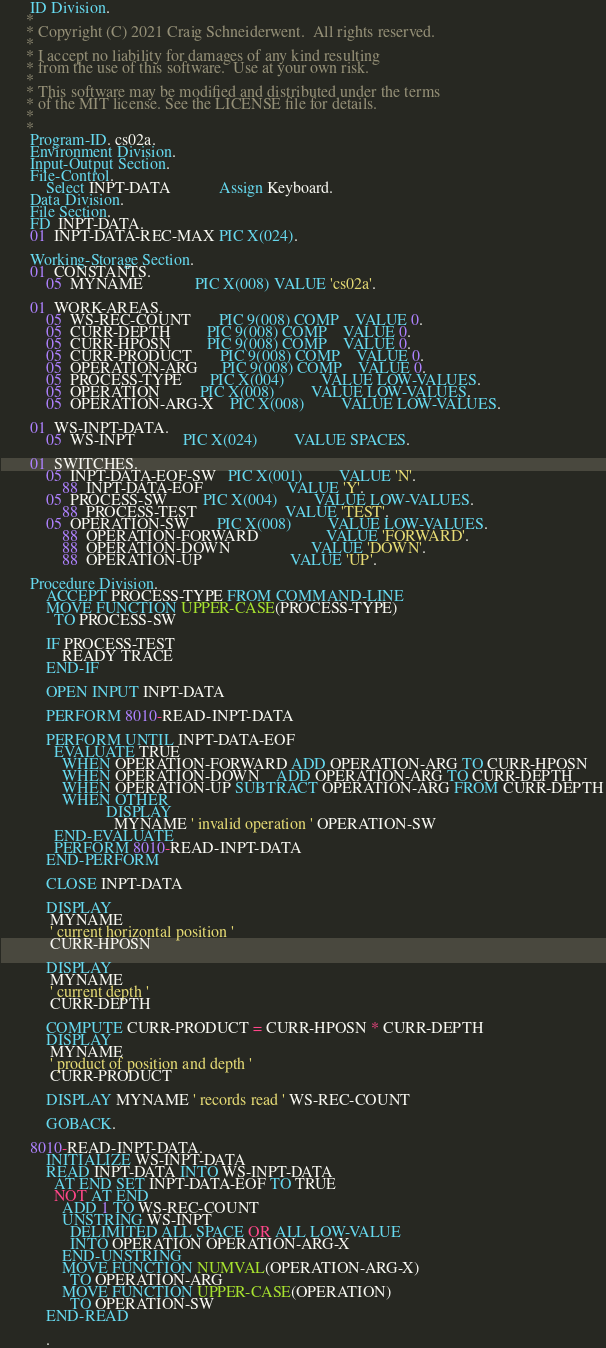<code> <loc_0><loc_0><loc_500><loc_500><_COBOL_>       ID Division.
      * 
      * Copyright (C) 2021 Craig Schneiderwent.  All rights reserved.
      * 
      * I accept no liability for damages of any kind resulting 
      * from the use of this software.  Use at your own risk.
      *
      * This software may be modified and distributed under the terms
      * of the MIT license. See the LICENSE file for details.
      *
      *
       Program-ID. cs02a.
       Environment Division.
       Input-Output Section.
       File-Control.
           Select INPT-DATA            Assign Keyboard.
       Data Division.
       File Section.
       FD  INPT-DATA.
       01  INPT-DATA-REC-MAX PIC X(024).

       Working-Storage Section.
       01  CONSTANTS.
           05  MYNAME             PIC X(008) VALUE 'cs02a'.

       01  WORK-AREAS.
           05  WS-REC-COUNT       PIC 9(008) COMP    VALUE 0.
           05  CURR-DEPTH         PIC 9(008) COMP    VALUE 0.
           05  CURR-HPOSN         PIC 9(008) COMP    VALUE 0.
           05  CURR-PRODUCT       PIC 9(008) COMP    VALUE 0.
           05  OPERATION-ARG      PIC 9(008) COMP    VALUE 0.
           05  PROCESS-TYPE       PIC X(004)         VALUE LOW-VALUES.
           05  OPERATION          PIC X(008)         VALUE LOW-VALUES.
           05  OPERATION-ARG-X    PIC X(008)         VALUE LOW-VALUES.

       01  WS-INPT-DATA.
           05  WS-INPT            PIC X(024)         VALUE SPACES.

       01  SWITCHES.
           05  INPT-DATA-EOF-SW   PIC X(001)         VALUE 'N'.
               88  INPT-DATA-EOF                     VALUE 'Y'.
           05  PROCESS-SW         PIC X(004)         VALUE LOW-VALUES.
               88  PROCESS-TEST                      VALUE 'TEST'.
           05  OPERATION-SW       PIC X(008)         VALUE LOW-VALUES.
               88  OPERATION-FORWARD                 VALUE 'FORWARD'.
               88  OPERATION-DOWN                    VALUE 'DOWN'.
               88  OPERATION-UP                      VALUE 'UP'.

       Procedure Division.
           ACCEPT PROCESS-TYPE FROM COMMAND-LINE
           MOVE FUNCTION UPPER-CASE(PROCESS-TYPE)
             TO PROCESS-SW

           IF PROCESS-TEST
               READY TRACE
           END-IF

           OPEN INPUT INPT-DATA

           PERFORM 8010-READ-INPT-DATA

           PERFORM UNTIL INPT-DATA-EOF
             EVALUATE TRUE
               WHEN OPERATION-FORWARD ADD OPERATION-ARG TO CURR-HPOSN
               WHEN OPERATION-DOWN    ADD OPERATION-ARG TO CURR-DEPTH
               WHEN OPERATION-UP SUBTRACT OPERATION-ARG FROM CURR-DEPTH
               WHEN OTHER
                          DISPLAY
                            MYNAME ' invalid operation ' OPERATION-SW
             END-EVALUATE
             PERFORM 8010-READ-INPT-DATA
           END-PERFORM

           CLOSE INPT-DATA

           DISPLAY
            MYNAME
            ' current horizontal position '
            CURR-HPOSN

           DISPLAY
            MYNAME
            ' current depth '
            CURR-DEPTH

           COMPUTE CURR-PRODUCT = CURR-HPOSN * CURR-DEPTH
           DISPLAY
            MYNAME
            ' product of position and depth '
            CURR-PRODUCT

           DISPLAY MYNAME ' records read ' WS-REC-COUNT

           GOBACK.

       8010-READ-INPT-DATA.
           INITIALIZE WS-INPT-DATA
           READ INPT-DATA INTO WS-INPT-DATA
             AT END SET INPT-DATA-EOF TO TRUE
             NOT AT END
               ADD 1 TO WS-REC-COUNT
               UNSTRING WS-INPT
                 DELIMITED ALL SPACE OR ALL LOW-VALUE
                 INTO OPERATION OPERATION-ARG-X
               END-UNSTRING
               MOVE FUNCTION NUMVAL(OPERATION-ARG-X)
                 TO OPERATION-ARG
               MOVE FUNCTION UPPER-CASE(OPERATION)
                 TO OPERATION-SW
           END-READ

           .


</code> 